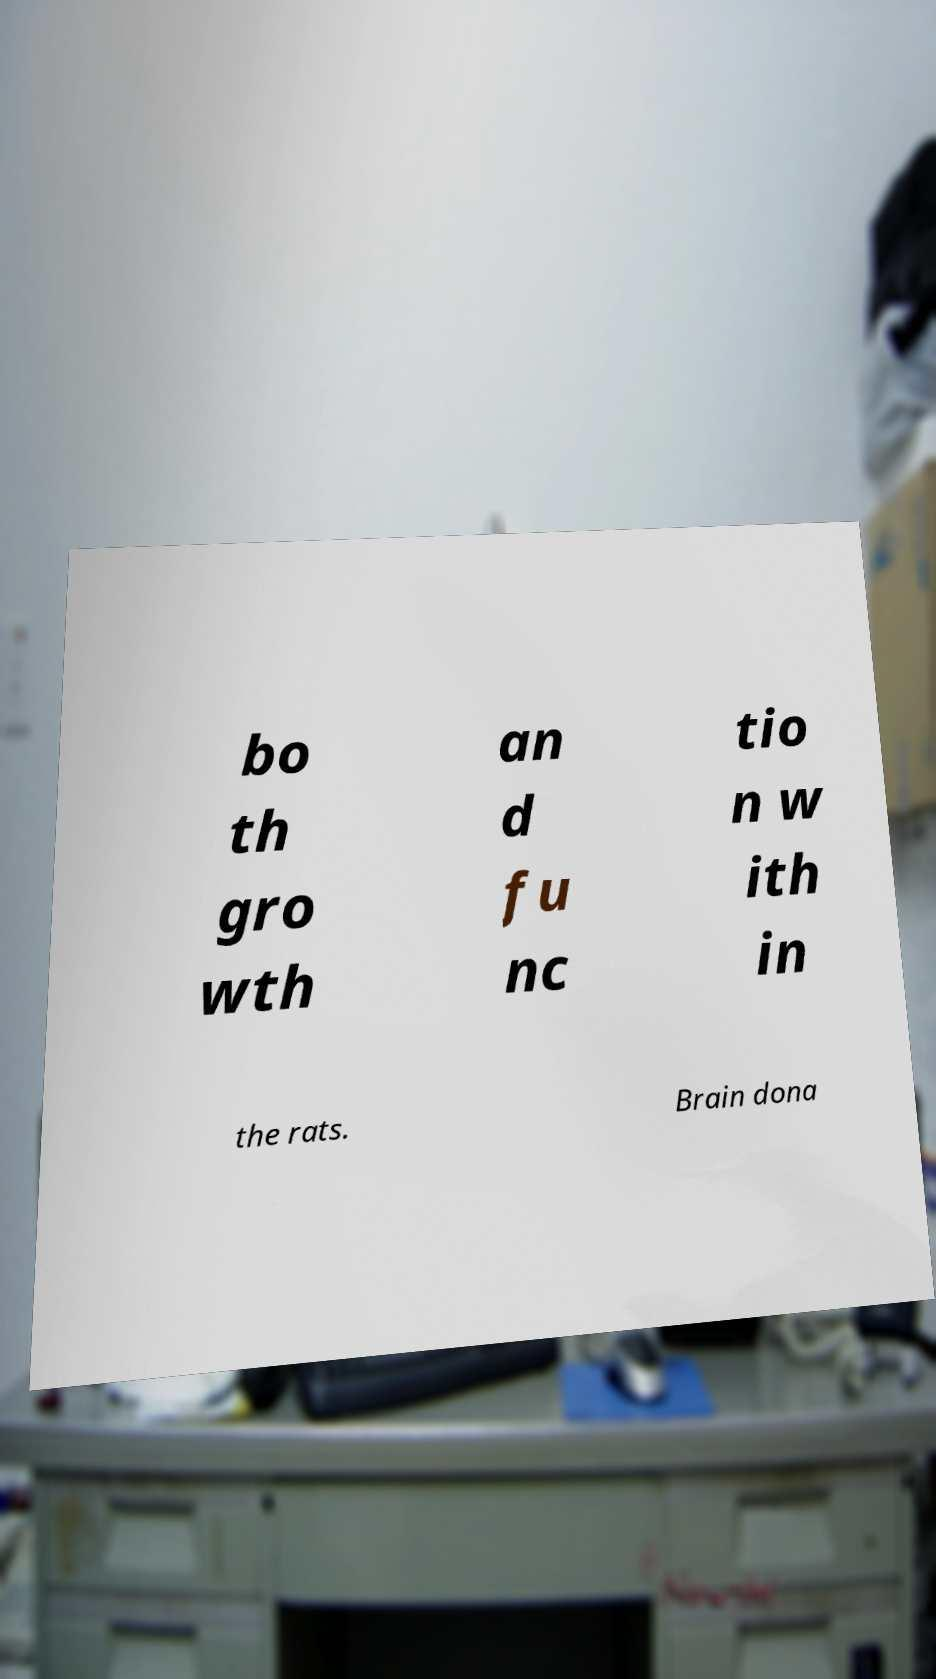There's text embedded in this image that I need extracted. Can you transcribe it verbatim? bo th gro wth an d fu nc tio n w ith in the rats. Brain dona 